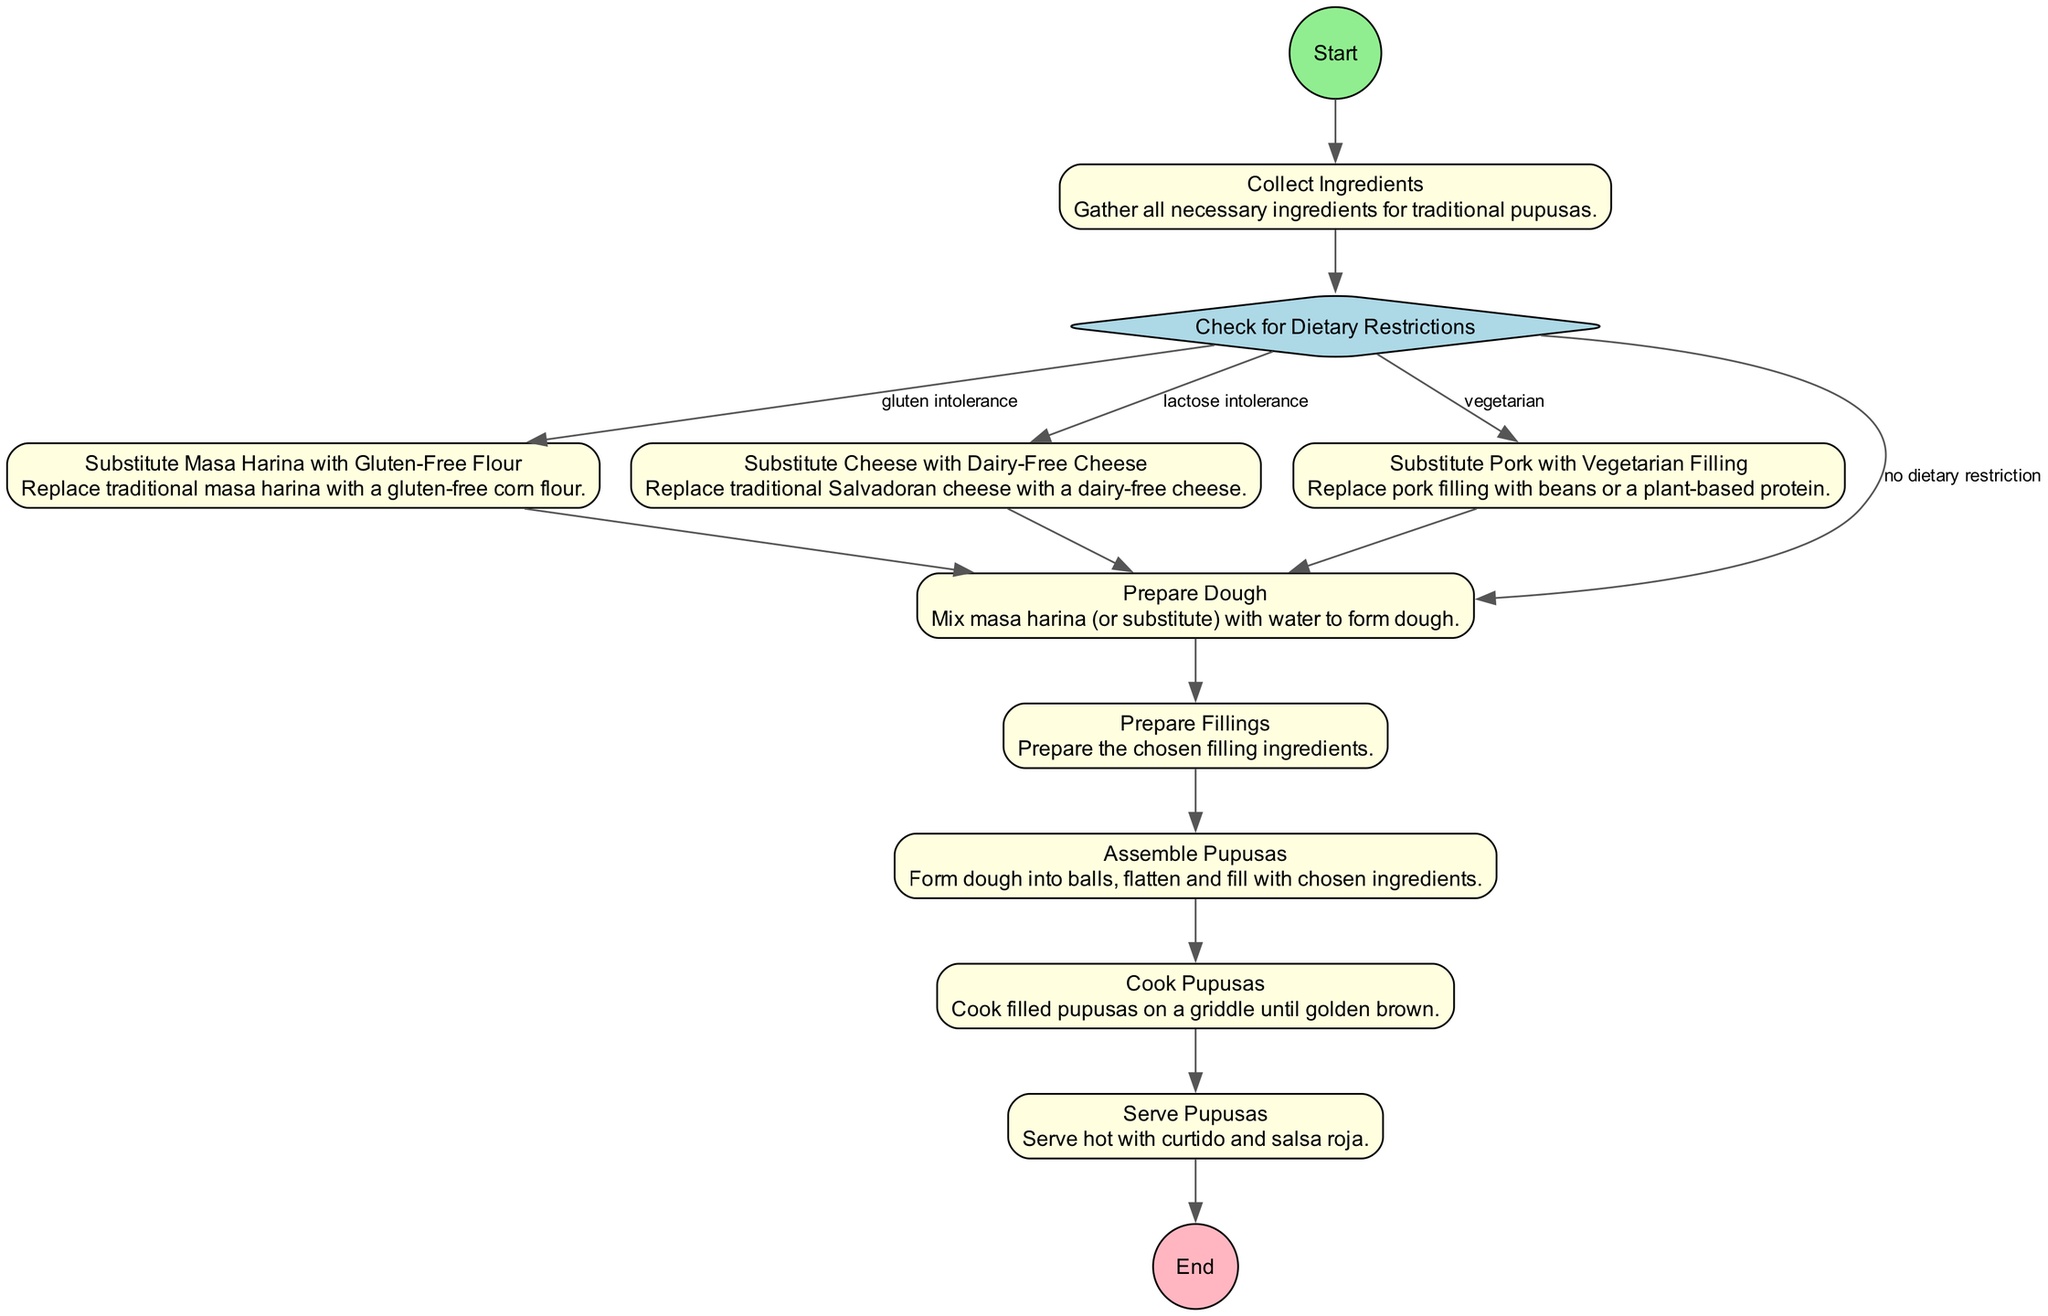What is the first step in the process? The diagram starts at the "Start" node, which is labeled as the initial action of the flowchart. This node represents the beginning of the pupusa recipe process.
Answer: Start How many tasks are involved in the pupusa recipe process? By examining the flowchart, we count the number of tasks listed. There are a total of six tasks related to the preparation and assembly of pupusas before serving.
Answer: Six What condition leads to substituting masa harina? The flowchart indicates that if there is a "gluten intolerance," it directs to the step for substituting masa harina with gluten-free flour. This establishes the necessary condition for this substitution.
Answer: Gluten intolerance What is the final step before serving the pupusas? The flowchart shows that after cooking the pupusas, the next step before reaching the end is to serve them. This helps clarify that serving is the concluding action in the recipe.
Answer: Serve Pupusas Which dietary restriction requires a filling substitution? According to the diagram, if the consumer is vegetarian, the process requires substituting pork with a vegetarian filling. This directly links the dietary restriction to a filling adjustment.
Answer: Vegetarian What node follows the preparation of dough? The flowchart outlines that after preparing the dough, the next step to proceed to is the preparation of fillings. This shows a direct sequence in the recipe process flow.
Answer: Prepare Fillings How does one proceed if there is no dietary restriction? The diagram specifies that if there are no dietary restrictions, the flow continues directly from checking the dietary restrictions to preparing the dough. This reveals how flexibility in the flow can impact the process.
Answer: Prepare Dough What type of ingredient can be used as a substitute for cheese? The flowchart states that if lactose intolerant, one should substitute traditional cheese with dairy-free cheese. Thus, this substitution is specifically indicated for lactose intolerance.
Answer: Dairy-Free Cheese 